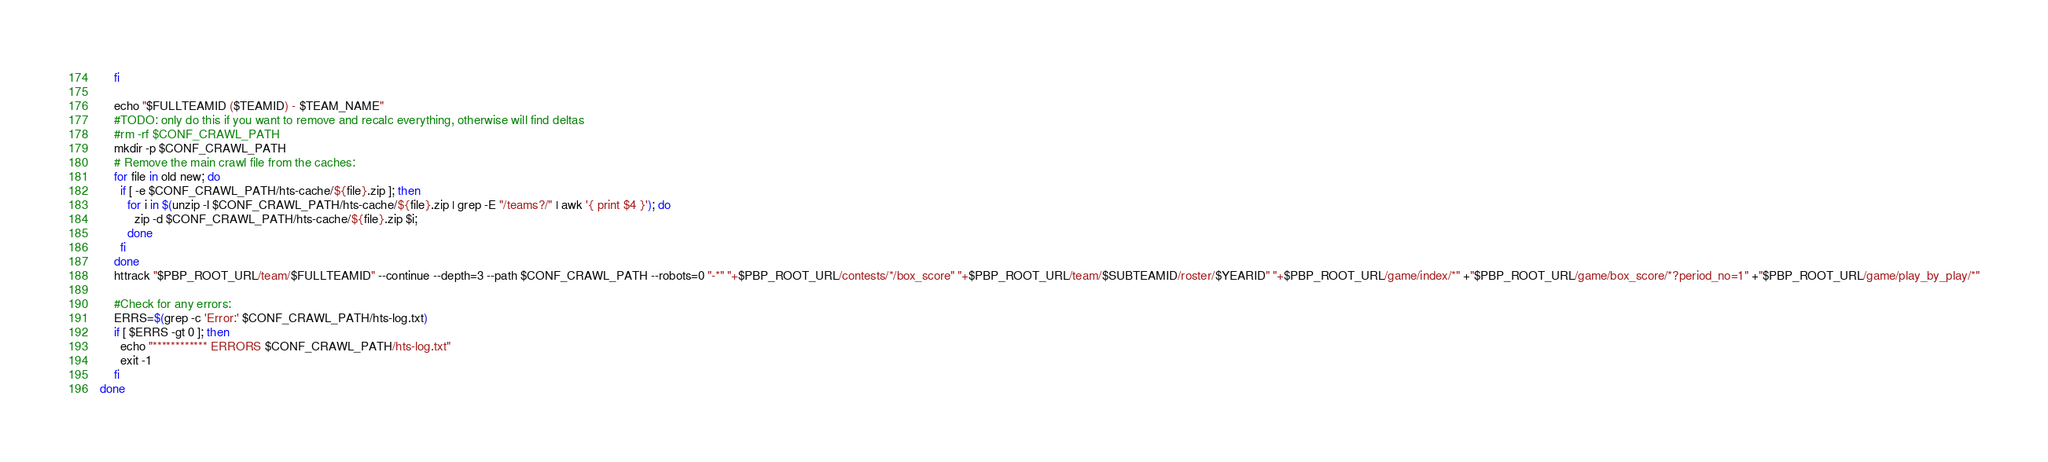<code> <loc_0><loc_0><loc_500><loc_500><_Bash_>    fi

    echo "$FULLTEAMID ($TEAMID) - $TEAM_NAME"
    #TODO: only do this if you want to remove and recalc everything, otherwise will find deltas
    #rm -rf $CONF_CRAWL_PATH
    mkdir -p $CONF_CRAWL_PATH
    # Remove the main crawl file from the caches:
    for file in old new; do
      if [ -e $CONF_CRAWL_PATH/hts-cache/${file}.zip ]; then
        for i in $(unzip -l $CONF_CRAWL_PATH/hts-cache/${file}.zip | grep -E "/teams?/" | awk '{ print $4 }'); do
          zip -d $CONF_CRAWL_PATH/hts-cache/${file}.zip $i;
        done
      fi
    done
    httrack "$PBP_ROOT_URL/team/$FULLTEAMID" --continue --depth=3 --path $CONF_CRAWL_PATH --robots=0 "-*" "+$PBP_ROOT_URL/contests/*/box_score" "+$PBP_ROOT_URL/team/$SUBTEAMID/roster/$YEARID" "+$PBP_ROOT_URL/game/index/*" +"$PBP_ROOT_URL/game/box_score/*?period_no=1" +"$PBP_ROOT_URL/game/play_by_play/*"

    #Check for any errors:
    ERRS=$(grep -c 'Error:' $CONF_CRAWL_PATH/hts-log.txt)
    if [ $ERRS -gt 0 ]; then
      echo "************ ERRORS $CONF_CRAWL_PATH/hts-log.txt"
      exit -1
    fi
done
</code> 